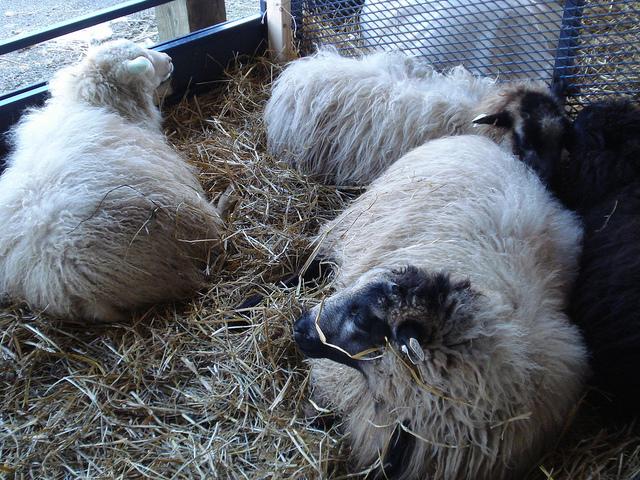Have they been sheared recently?
Concise answer only. No. What color is the fence?
Quick response, please. Blue. What are they laying in?
Quick response, please. Hay. 